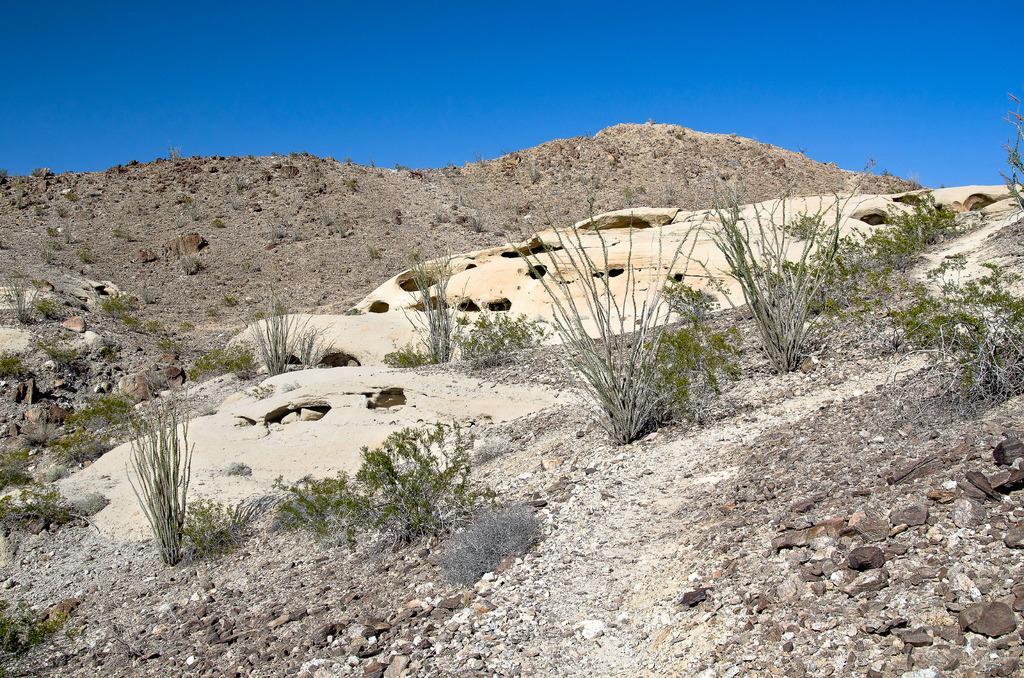How would you summarize this image in a sentence or two? In this image at the bottom there are some mountains, plants, small stones and grass, on the top of the image there is sky. 